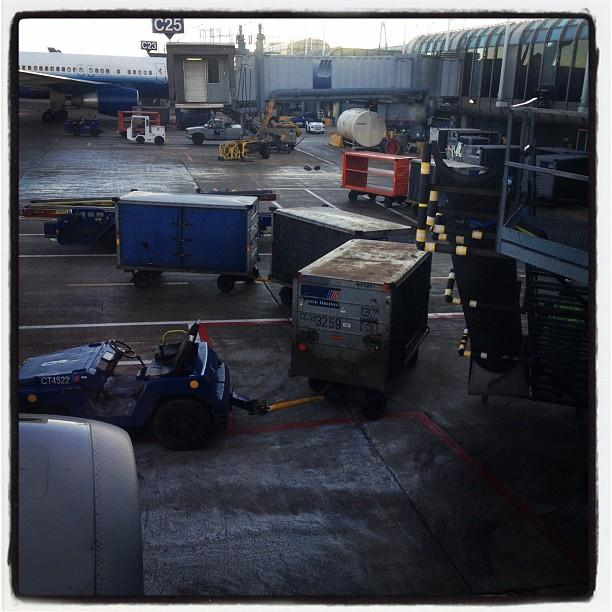What is the blue vehicle doing?

Choices:
A) pulling
B) overturning
C) sinking
D) burning pulling 